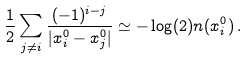<formula> <loc_0><loc_0><loc_500><loc_500>\frac { 1 } { 2 } \sum _ { j \neq i } \frac { ( - 1 ) ^ { i - j } } { | x _ { i } ^ { 0 } - x _ { j } ^ { 0 } | } \simeq - \log ( 2 ) n ( x ^ { 0 } _ { i } ) \, .</formula> 